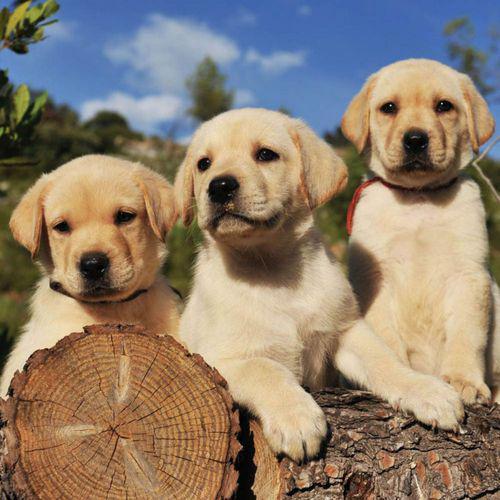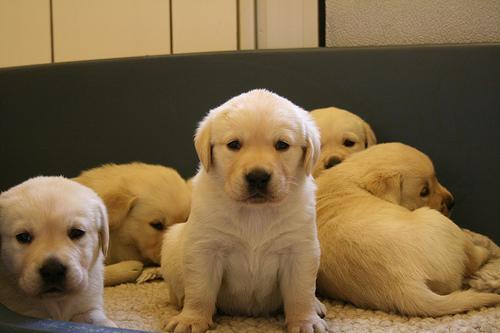The first image is the image on the left, the second image is the image on the right. For the images shown, is this caption "There are exactly five dogs in the image on the left." true? Answer yes or no. No. The first image is the image on the left, the second image is the image on the right. Examine the images to the left and right. Is the description "There is one black dog" accurate? Answer yes or no. No. 